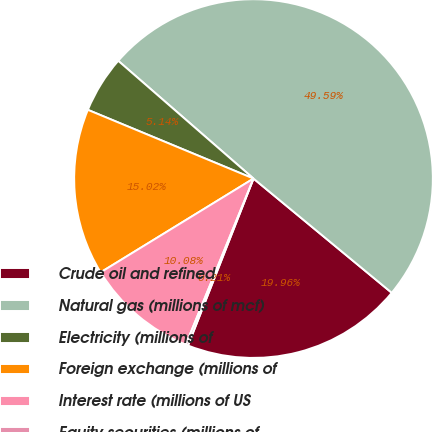<chart> <loc_0><loc_0><loc_500><loc_500><pie_chart><fcel>Crude oil and refined<fcel>Natural gas (millions of mcf)<fcel>Electricity (millions of<fcel>Foreign exchange (millions of<fcel>Interest rate (millions of US<fcel>Equity securities (millions of<nl><fcel>19.96%<fcel>49.59%<fcel>5.14%<fcel>15.02%<fcel>10.08%<fcel>0.21%<nl></chart> 